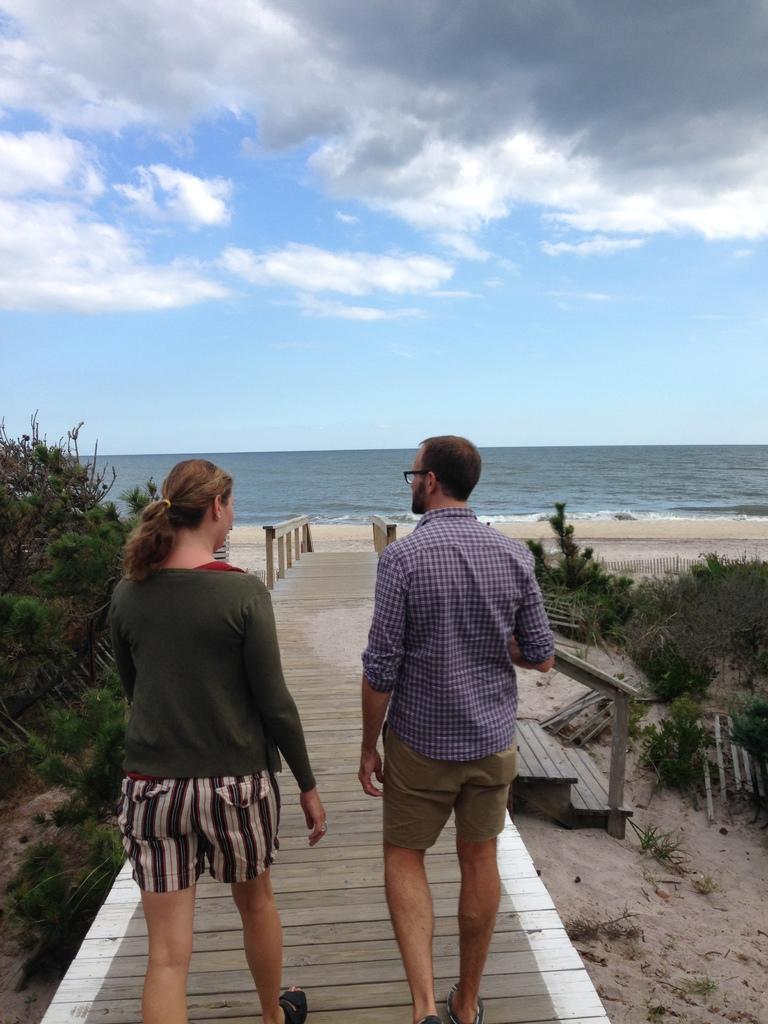In one or two sentences, can you explain what this image depicts? In this image, we can see a man and a woman walking on the walkway, there are some plants. We can see water, at the top we can see the sky. 